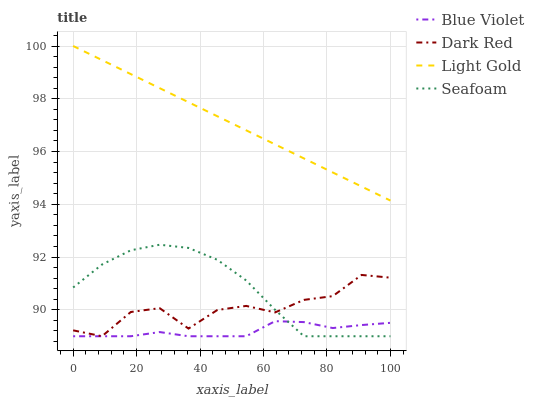Does Blue Violet have the minimum area under the curve?
Answer yes or no. Yes. Does Light Gold have the maximum area under the curve?
Answer yes or no. Yes. Does Seafoam have the minimum area under the curve?
Answer yes or no. No. Does Seafoam have the maximum area under the curve?
Answer yes or no. No. Is Light Gold the smoothest?
Answer yes or no. Yes. Is Dark Red the roughest?
Answer yes or no. Yes. Is Seafoam the smoothest?
Answer yes or no. No. Is Seafoam the roughest?
Answer yes or no. No. Does Dark Red have the lowest value?
Answer yes or no. Yes. Does Light Gold have the lowest value?
Answer yes or no. No. Does Light Gold have the highest value?
Answer yes or no. Yes. Does Seafoam have the highest value?
Answer yes or no. No. Is Dark Red less than Light Gold?
Answer yes or no. Yes. Is Light Gold greater than Seafoam?
Answer yes or no. Yes. Does Blue Violet intersect Dark Red?
Answer yes or no. Yes. Is Blue Violet less than Dark Red?
Answer yes or no. No. Is Blue Violet greater than Dark Red?
Answer yes or no. No. Does Dark Red intersect Light Gold?
Answer yes or no. No. 